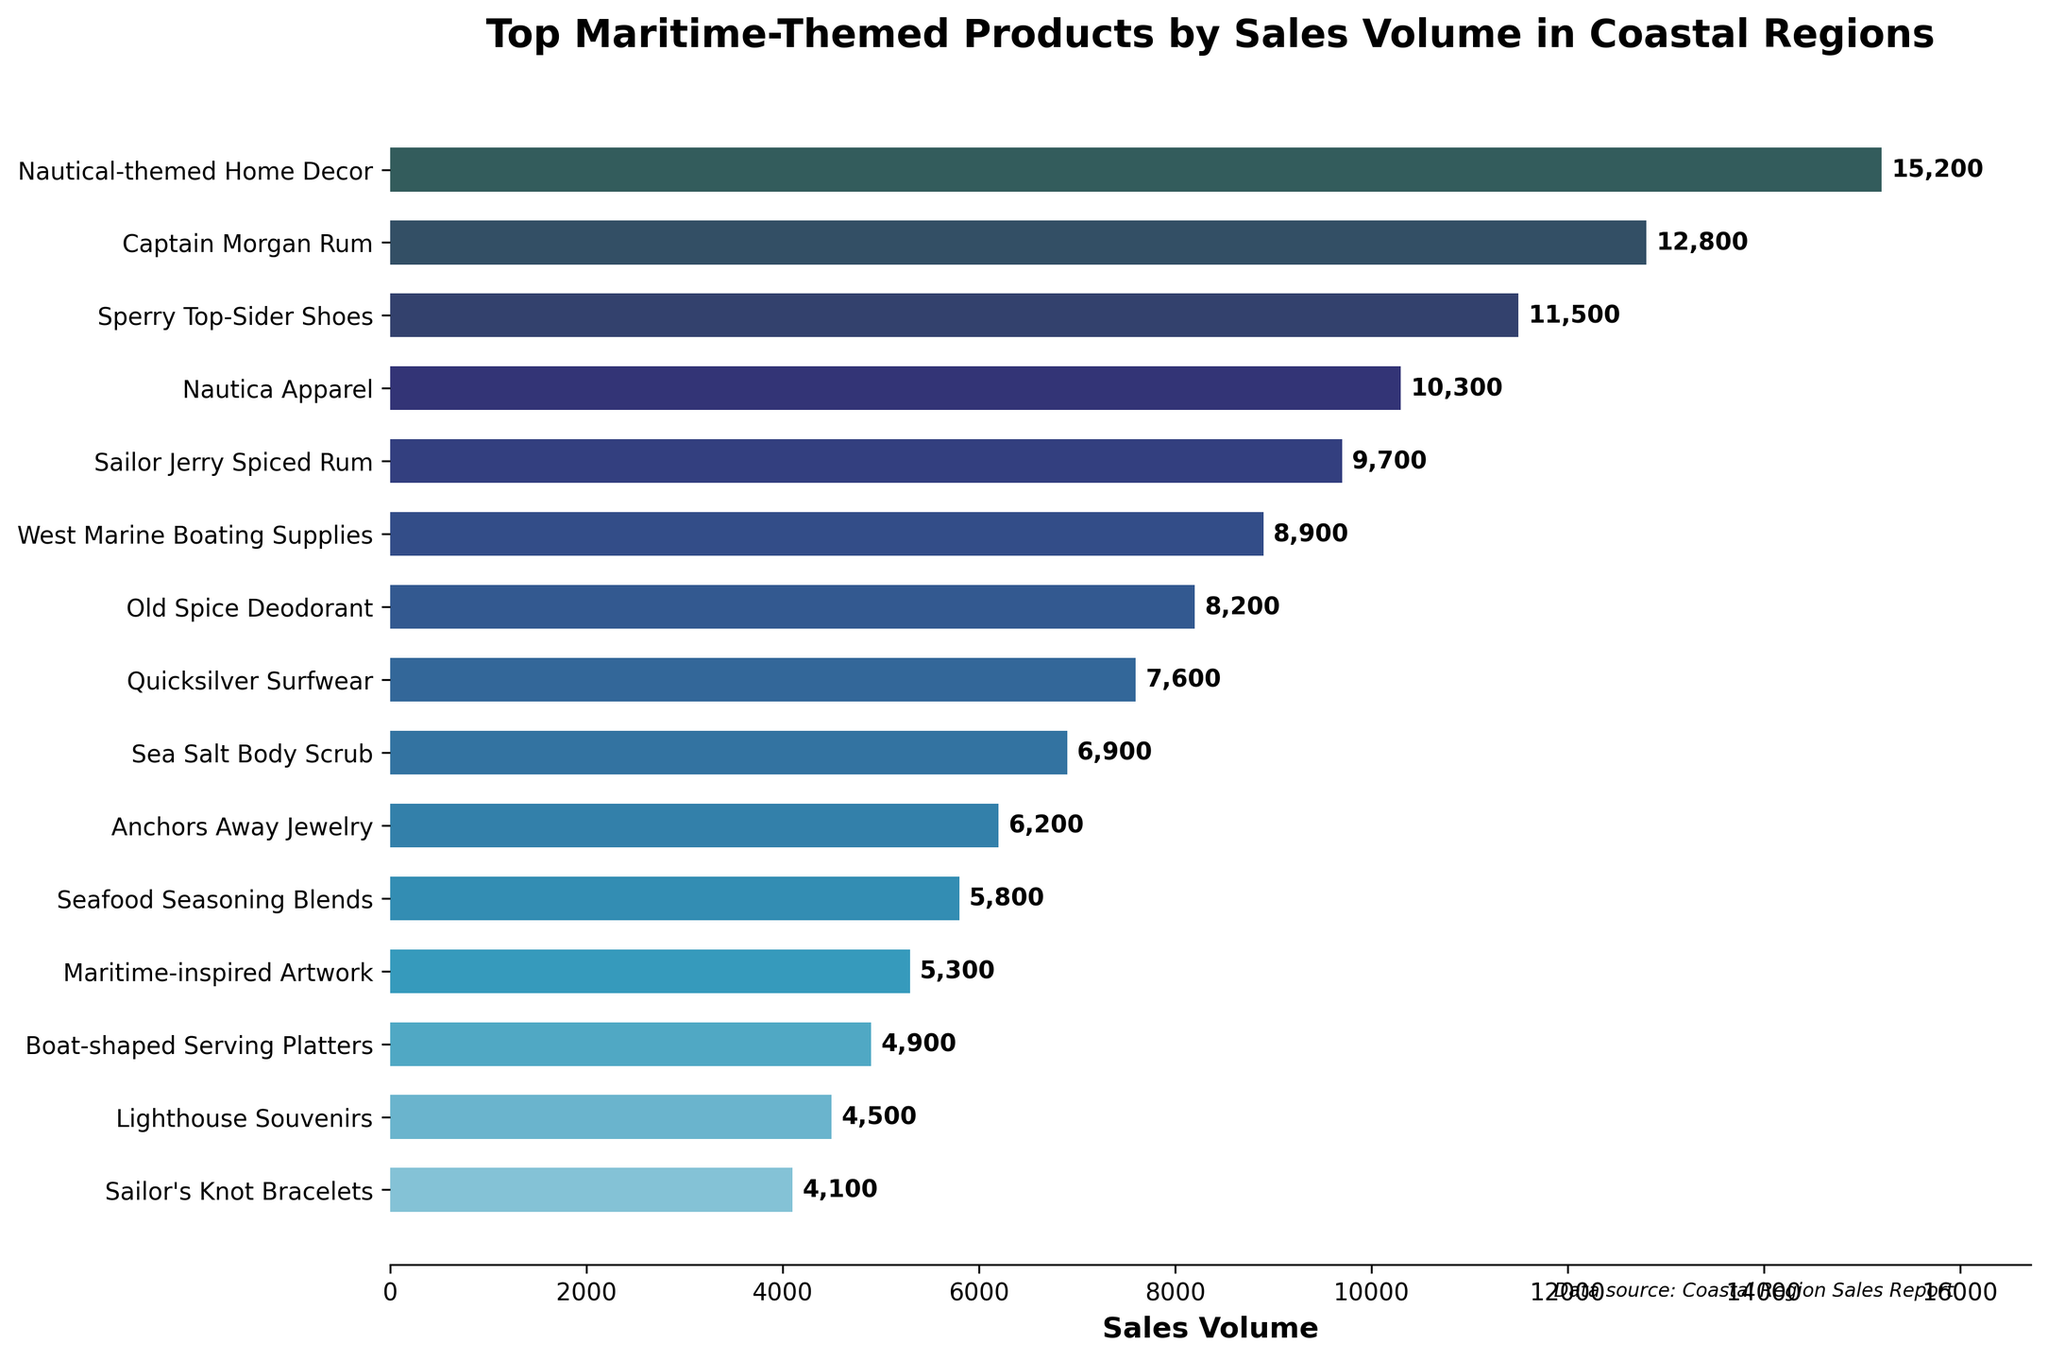Which product has the highest sales volume? The highest bar on the chart represents the product with the highest sales volume. Nautical-themed Home Decor is at the top of the chart with the highest bar.
Answer: Nautical-themed Home Decor What is the combined sales volume of Captain Morgan Rum and Sailor Jerry Spiced Rum? From the chart, the sales volume of Captain Morgan Rum is 12,800 and Sailor Jerry Spiced Rum is 9,700. Adding these together gives 12,800 + 9,700 = 22,500.
Answer: 22,500 Which product has a higher sales volume, Nautica Apparel or Old Spice Deodorant? By comparing the lengths of the bars for these two products, we see that Nautica Apparel has a sales volume of 10,300, while Old Spice Deodorant has a sales volume of 8,200. Therefore, Nautica Apparel has a higher sales volume.
Answer: Nautica Apparel How much greater is the sales volume of Sperry Top-Sider Shoes compared to Anchors Away Jewelry? The sales volume of Sperry Top-Sider Shoes is 11,500 and Anchors Away Jewelry is 6,200. The difference is 11,500 - 6,200 = 5,300.
Answer: 5,300 What is the average sales volume of the top three products? The top three products by sales volume are Nautical-themed Home Decor (15,200), Captain Morgan Rum (12,800), and Sperry Top-Sider Shoes (11,500). Their total sales volume is 15,200 + 12,800 + 11,500 = 39,500. The average is 39,500 / 3 = 13,167 (rounded to the nearest whole number).
Answer: 13,167 Which product has the shortest bar on the chart? The shortest bar on the chart corresponds to Sailor's Knot Bracelets, which is at the bottom with a sales volume of 4,100.
Answer: Sailor's Knot Bracelets How does the sales volume of Quicksilver Surfwear compare to Seafood Seasoning Blends? Quicksilver Surfwear has a sales volume of 7,600 while Seafood Seasoning Blends has a sales volume of 5,800. Hence, Quicksilver Surfwear has a higher sales volume.
Answer: Quicksilver Surfwear What is the sales volume difference between West Marine Boating Supplies and Boat-shaped Serving Platters? The sales volume for West Marine Boating Supplies is 8,900 and for Boat-shaped Serving Platters is 4,900. The difference is 8,900 - 4,900 = 4,000.
Answer: 4,000 